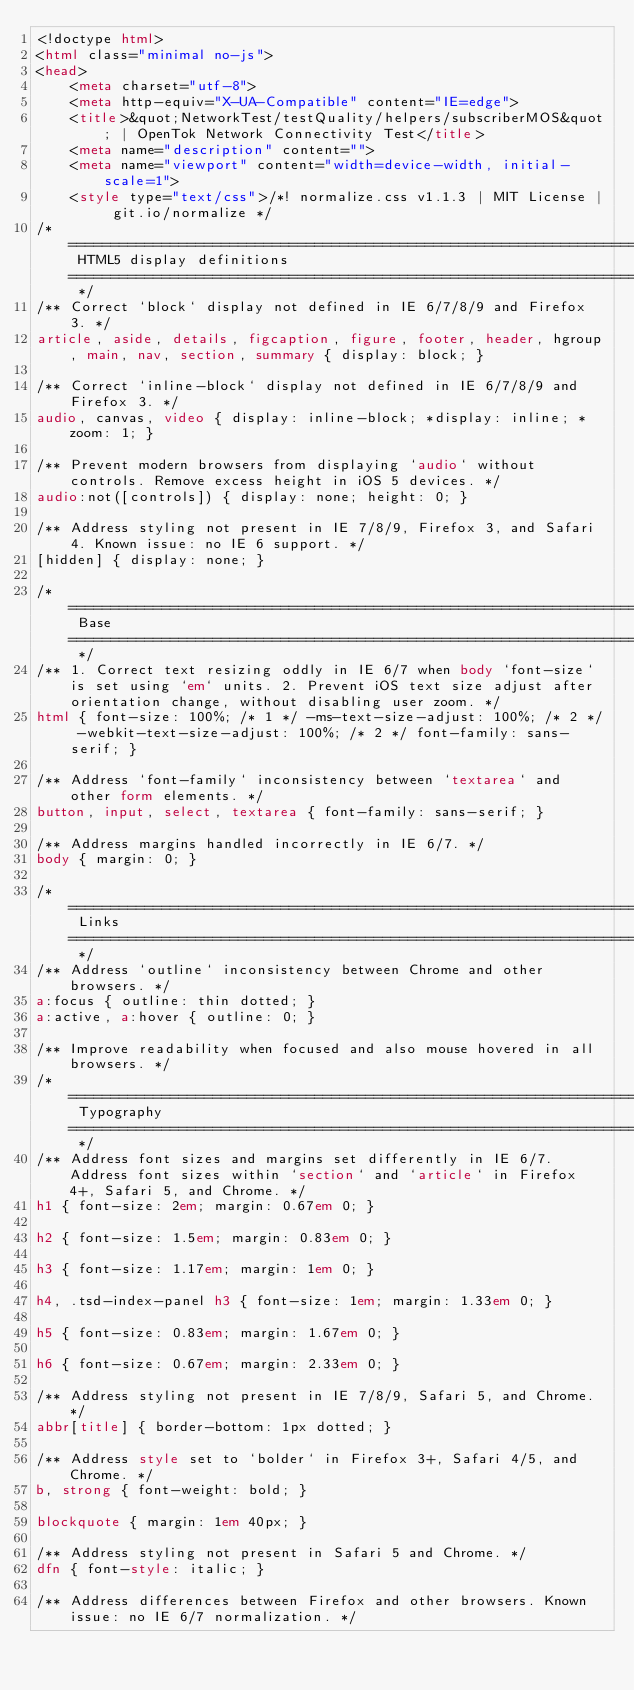<code> <loc_0><loc_0><loc_500><loc_500><_HTML_><!doctype html>
<html class="minimal no-js">
<head>
	<meta charset="utf-8">
	<meta http-equiv="X-UA-Compatible" content="IE=edge">
	<title>&quot;NetworkTest/testQuality/helpers/subscriberMOS&quot; | OpenTok Network Connectivity Test</title>
	<meta name="description" content="">
	<meta name="viewport" content="width=device-width, initial-scale=1">
	<style type="text/css">/*! normalize.css v1.1.3 | MIT License | git.io/normalize */
/* ========================================================================== HTML5 display definitions ========================================================================== */
/** Correct `block` display not defined in IE 6/7/8/9 and Firefox 3. */
article, aside, details, figcaption, figure, footer, header, hgroup, main, nav, section, summary { display: block; }

/** Correct `inline-block` display not defined in IE 6/7/8/9 and Firefox 3. */
audio, canvas, video { display: inline-block; *display: inline; *zoom: 1; }

/** Prevent modern browsers from displaying `audio` without controls. Remove excess height in iOS 5 devices. */
audio:not([controls]) { display: none; height: 0; }

/** Address styling not present in IE 7/8/9, Firefox 3, and Safari 4. Known issue: no IE 6 support. */
[hidden] { display: none; }

/* ========================================================================== Base ========================================================================== */
/** 1. Correct text resizing oddly in IE 6/7 when body `font-size` is set using `em` units. 2. Prevent iOS text size adjust after orientation change, without disabling user zoom. */
html { font-size: 100%; /* 1 */ -ms-text-size-adjust: 100%; /* 2 */ -webkit-text-size-adjust: 100%; /* 2 */ font-family: sans-serif; }

/** Address `font-family` inconsistency between `textarea` and other form elements. */
button, input, select, textarea { font-family: sans-serif; }

/** Address margins handled incorrectly in IE 6/7. */
body { margin: 0; }

/* ========================================================================== Links ========================================================================== */
/** Address `outline` inconsistency between Chrome and other browsers. */
a:focus { outline: thin dotted; }
a:active, a:hover { outline: 0; }

/** Improve readability when focused and also mouse hovered in all browsers. */
/* ========================================================================== Typography ========================================================================== */
/** Address font sizes and margins set differently in IE 6/7. Address font sizes within `section` and `article` in Firefox 4+, Safari 5, and Chrome. */
h1 { font-size: 2em; margin: 0.67em 0; }

h2 { font-size: 1.5em; margin: 0.83em 0; }

h3 { font-size: 1.17em; margin: 1em 0; }

h4, .tsd-index-panel h3 { font-size: 1em; margin: 1.33em 0; }

h5 { font-size: 0.83em; margin: 1.67em 0; }

h6 { font-size: 0.67em; margin: 2.33em 0; }

/** Address styling not present in IE 7/8/9, Safari 5, and Chrome. */
abbr[title] { border-bottom: 1px dotted; }

/** Address style set to `bolder` in Firefox 3+, Safari 4/5, and Chrome. */
b, strong { font-weight: bold; }

blockquote { margin: 1em 40px; }

/** Address styling not present in Safari 5 and Chrome. */
dfn { font-style: italic; }

/** Address differences between Firefox and other browsers. Known issue: no IE 6/7 normalization. */</code> 